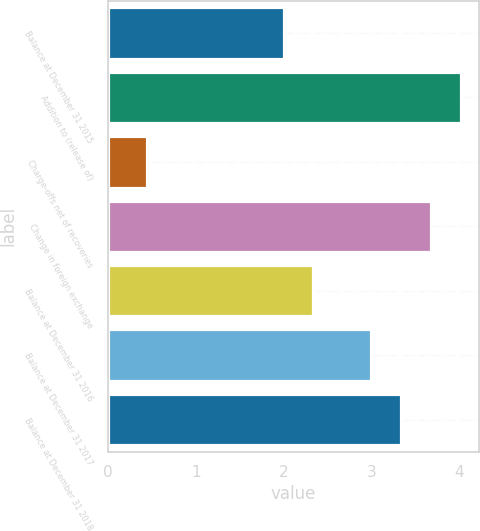Convert chart to OTSL. <chart><loc_0><loc_0><loc_500><loc_500><bar_chart><fcel>Balance at December 31 2015<fcel>Addition to (release of)<fcel>Charge-offs net of recoveries<fcel>Change in foreign exchange<fcel>Balance at December 31 2016<fcel>Balance at December 31 2017<fcel>Balance at December 31 2018<nl><fcel>2<fcel>4.02<fcel>0.45<fcel>3.68<fcel>2.34<fcel>3<fcel>3.34<nl></chart> 